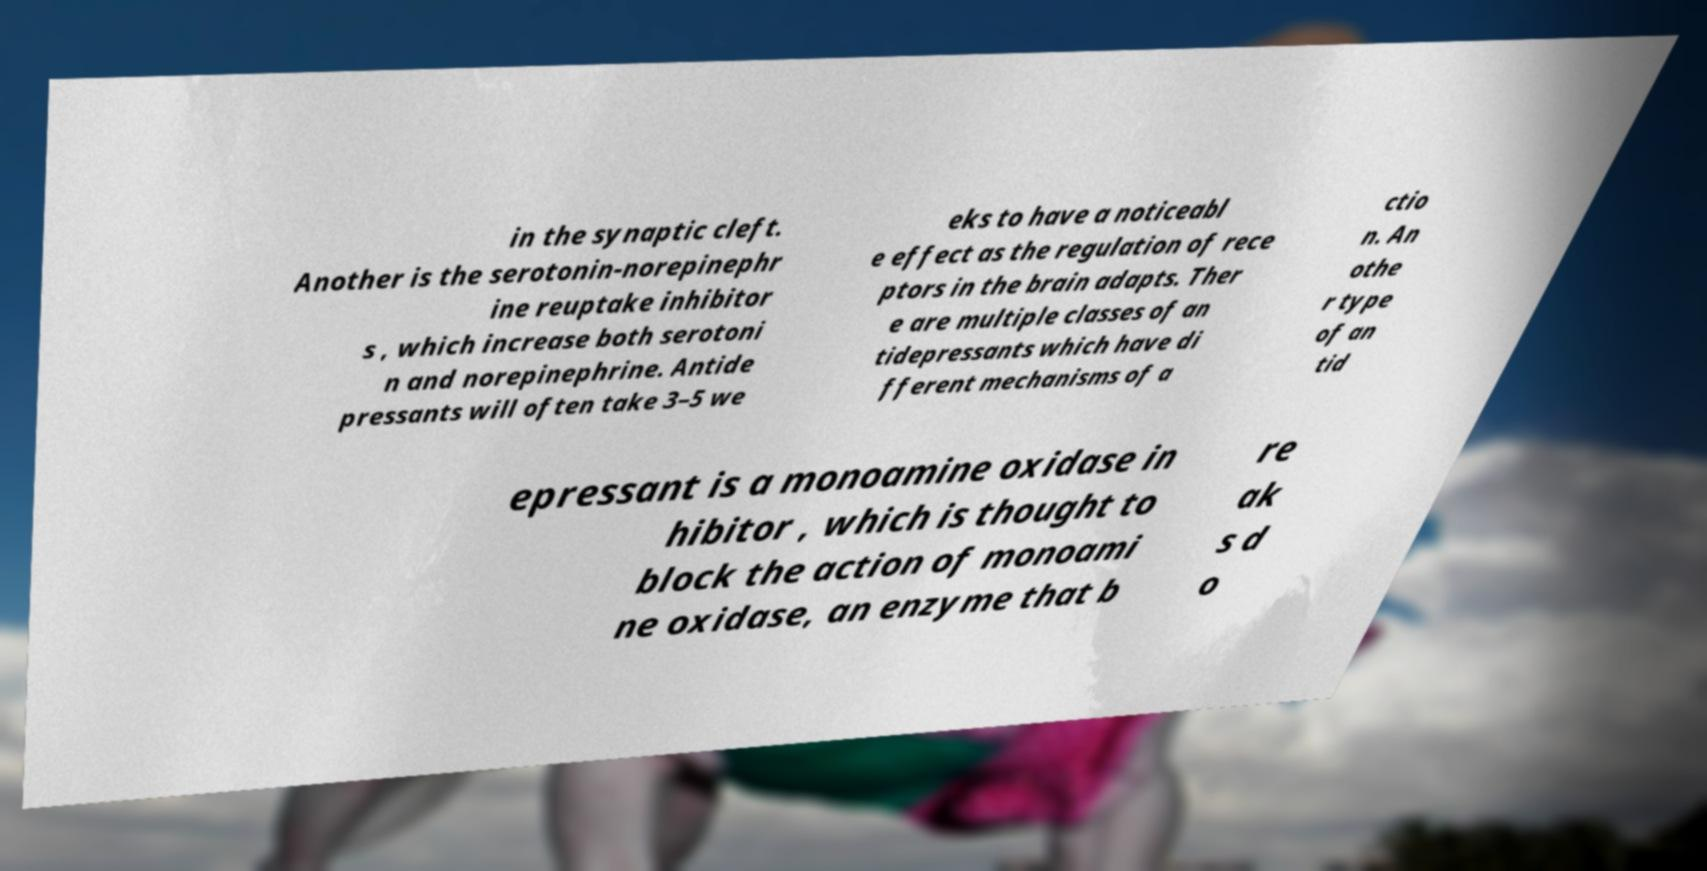Please identify and transcribe the text found in this image. in the synaptic cleft. Another is the serotonin-norepinephr ine reuptake inhibitor s , which increase both serotoni n and norepinephrine. Antide pressants will often take 3–5 we eks to have a noticeabl e effect as the regulation of rece ptors in the brain adapts. Ther e are multiple classes of an tidepressants which have di fferent mechanisms of a ctio n. An othe r type of an tid epressant is a monoamine oxidase in hibitor , which is thought to block the action of monoami ne oxidase, an enzyme that b re ak s d o 